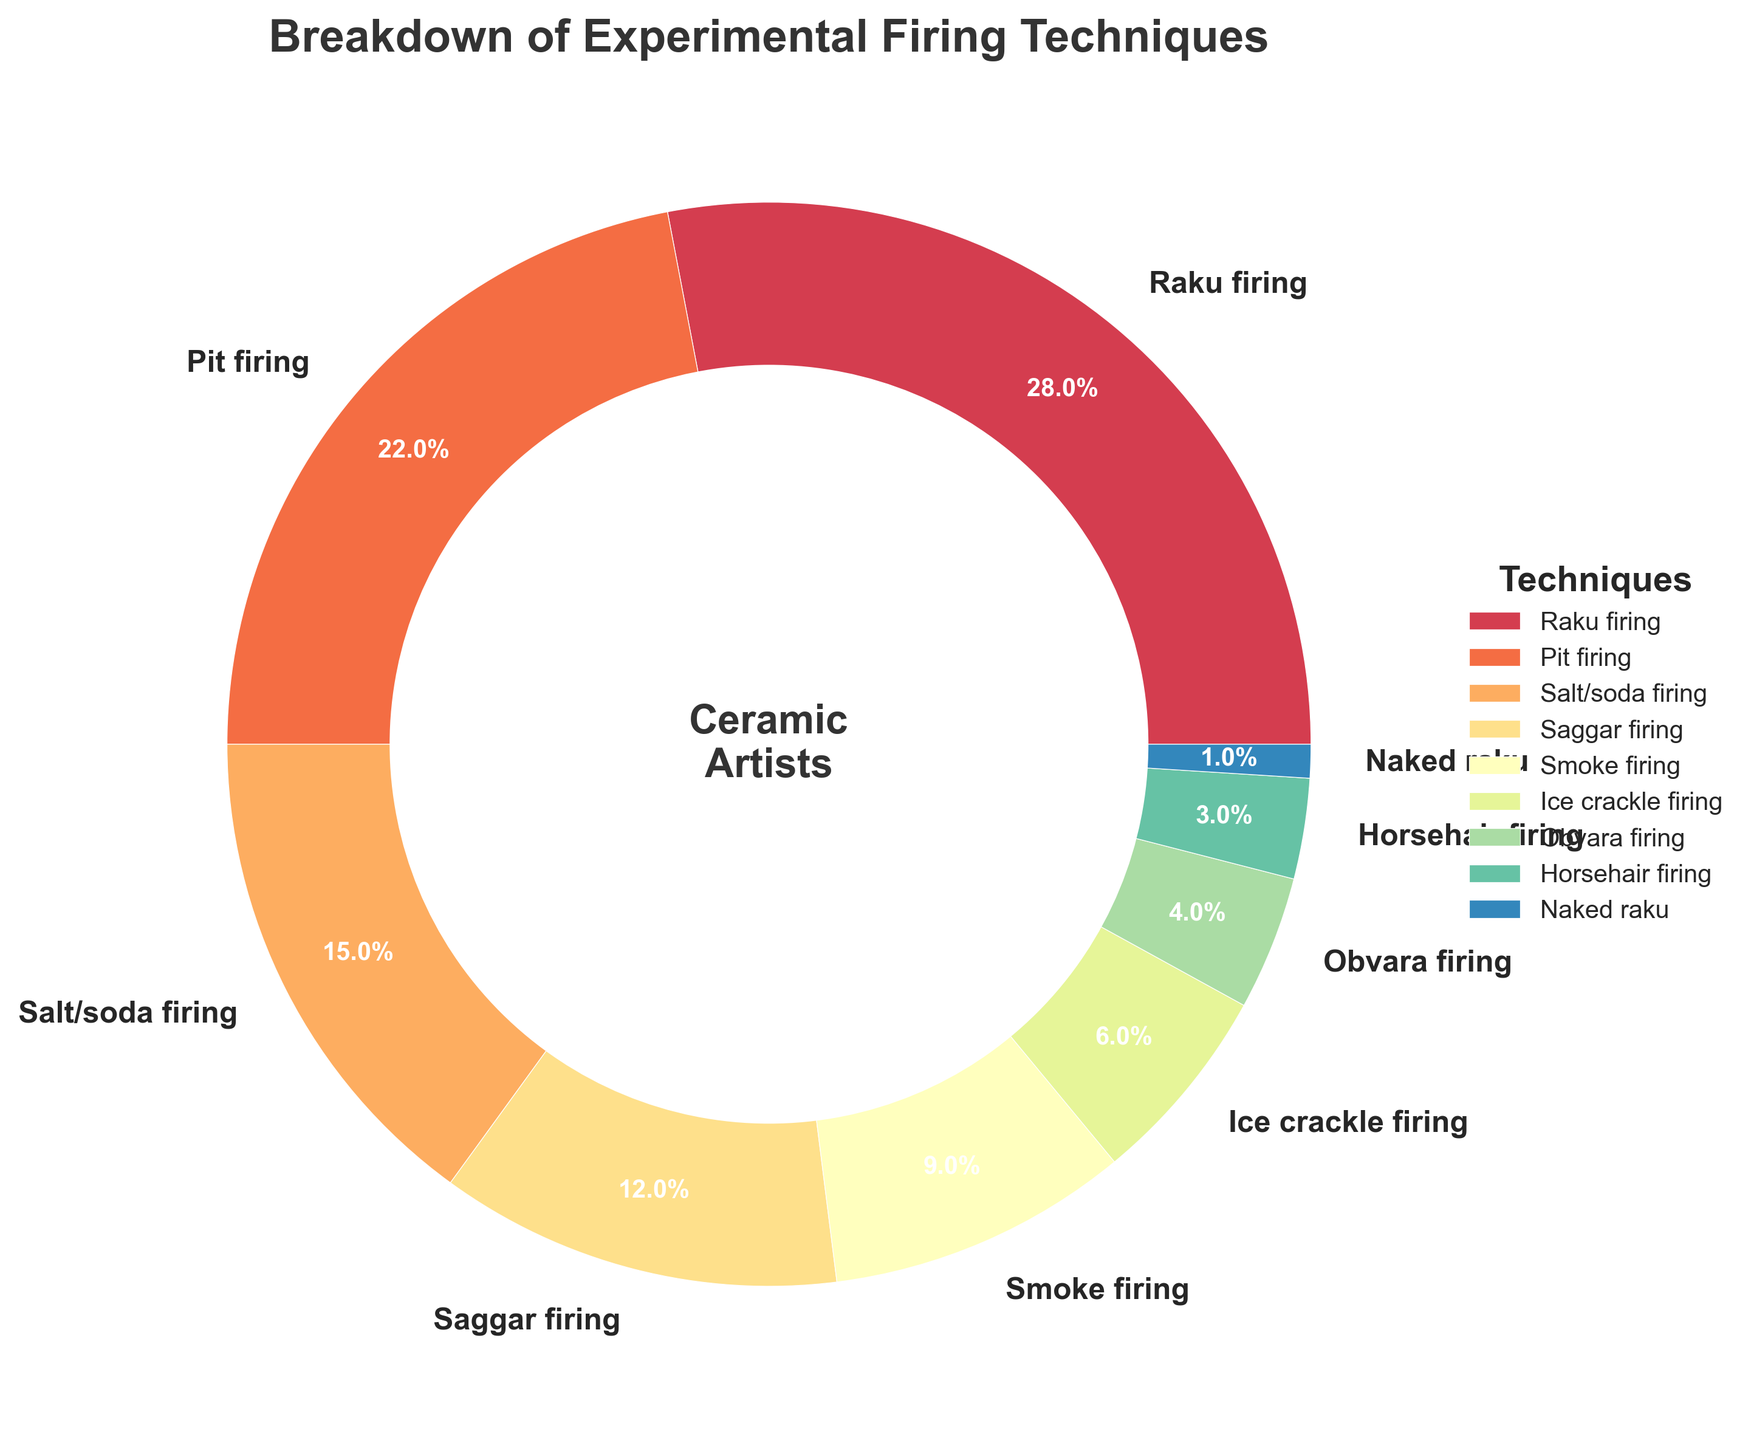What's the most frequently used experimental firing technique according to the chart? First, locate the wedge with the largest percentage. The label "Raku firing" shows 28%, which is the highest percentage among the techniques displayed in the chart.
Answer: Raku firing What percentage of artists use Horsehair firing and Naked raku combined? Identify the wedges labeled "Horsehair firing" (3%) and "Naked raku" (1%). Add these percentages together: 3% + 1% = 4%.
Answer: 4% Which technique is used by more artists: Salt/soda firing or Saggar firing? Find the percentages for each technique. Salt/soda firing has 15%, while Saggar firing has 12%. Compare the two values to see which is larger.
Answer: Salt/soda firing How many firing techniques are used by 5% or less of the artists? Identify the techniques that fall into this category: Ice crackle firing (6%), Obvara firing (4%), Horsehair firing (3%), and Naked raku (1%). Total = 4 techniques.
Answer: 4 Which technique is the least used by contemporary ceramic artists? Locate the wedge with the smallest percentage. The label "Naked raku" shows 1%, which is the smallest percentage among the techniques.
Answer: Naked raku Is the combined usage of Pit firing and Smoke firing more or less than the usage of Raku firing? Add the percentages of Pit firing (22%) and Smoke firing (9%): 22% + 9% = 31%. Compare this total with the percentage of Raku firing (28%).
Answer: More What is the total percentage of artists that use alternative firing techniques excluding the top three techniques? Identify the top three techniques by their percentages (Raku firing, Pit firing, and Salt/soda firing: 28%, 22%, 15%). Exclude these from the total 100%, and find the remaining sum: 100% - (28% + 22% + 15%) = 35%.
Answer: 35% What percentage of artists prefer Raku firing over Smoke firing? Find the difference in the percentages between Raku firing (28%) and Smoke firing (9%): 28% - 9% = 19%.
Answer: 19% Which four techniques collectively make up more than half of the percentages on the chart? Identify the top percentage techniques until the sum exceeds 50%. These are Raku firing (28%), Pit firing (22%), Salt/soda firing (15%), and Saggar firing (12%). Sum: 28% + 22% + 15% + 12% = 77%.
Answer: Raku firing, Pit firing, Salt/soda firing, Saggar firing 